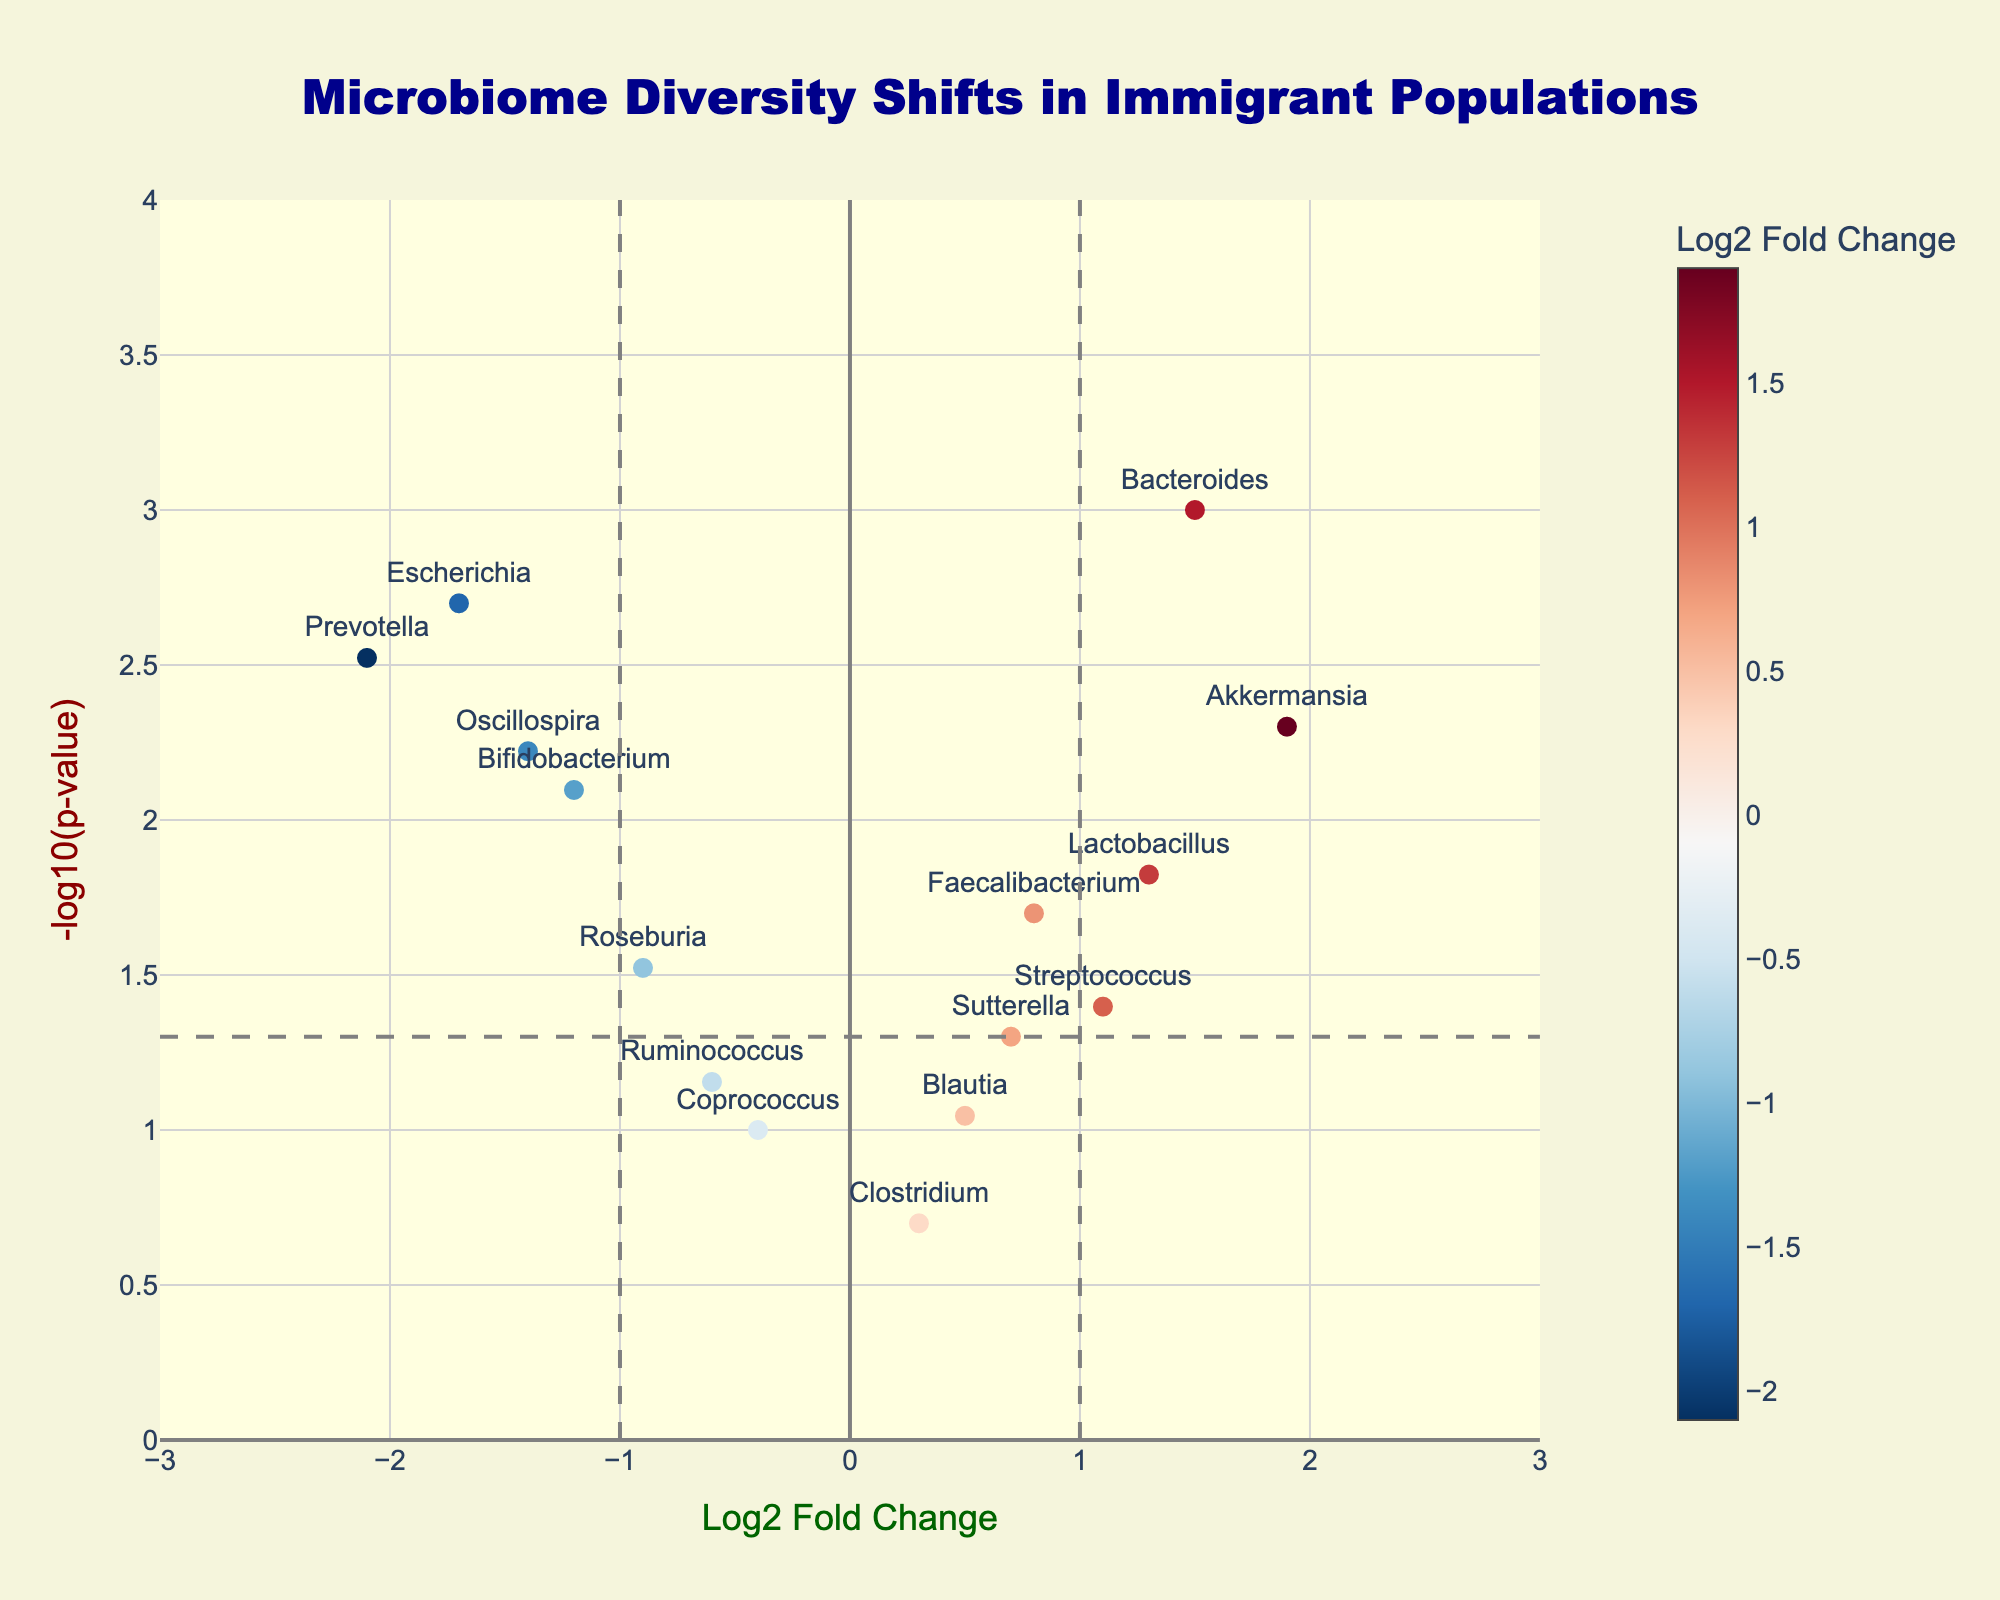Which gene has the highest Log2 Fold Change? From the graph, the highest Log2 Fold Change corresponds to the rightmost point on the x-axis. The gene labeled there is Akkermansia.
Answer: Akkermansia Which gene has the lowest p-value? The lowest p-value can be found by looking for the highest point on the y-axis (-log10(p-value)). The highest point represents the smallest p-value, which corresponds to Bacteroides.
Answer: Bacteroides How many genes have a Log2 Fold Change greater than 1? To find the number of genes with a Log2 Fold Change greater than 1, count the number of data points to the right of the vertical line at Log2 Fold Change = 1. There are three such genes: Akkermansia, Bacteroides, and Lactobacillus.
Answer: 3 Which gene is closest to the threshold line of p-value = 0.05? The threshold line for p-value = 0.05 is represented by the horizontal gray dashed line at y = -log10(0.05). The gene whose point is closest to this line is Sutterella.
Answer: Sutterella What is the Log2 Fold Change of Escherichia? Locate the gene Escherichia on the plot and refer to its x-value. Escherichia is positioned at a Log2 Fold Change of -1.7.
Answer: -1.7 Is Bacteroides more or less statistically significant than Prevotella? Statistical significance is indicated by the height of the point on the y-axis. Since Bacteroides is higher on the y-axis than Prevotella, it has a lower p-value (meaning more statistically significant).
Answer: more How many genes have a p-value less than or equal to 0.05? Look for all points above the horizontal line at y = -log10(0.05), which represents genes with p-values less than or equal to 0.05. Counting these points, there are ten such genes.
Answer: 10 Which genes have a negative Log2 Fold Change and are considered statistically significant (p-value ≤ 0.05)? Identify points with a Log2 Fold Change less than zero (left of the vertical center line) and above the horizontal threshold line at y = -log10(0.05). These genes are Prevotella, Bifidobacterium, Escherichia, Roseburia, and Oscillospira.
Answer: Prevotella, Bifidobacterium, Escherichia, Roseburia, Oscillospira What is the -log10(p-value) for Lactobacillus? Locate Lactobacillus on the plot and refer to its y-value, which represents -log10(p-value). Lactobacillus has a -log10(p-value) of approximately 1.82.
Answer: ~1.82 